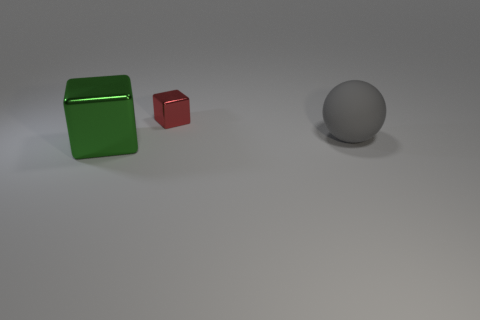Subtract all red blocks. How many blocks are left? 1 Add 2 gray metal blocks. How many objects exist? 5 Subtract 0 red cylinders. How many objects are left? 3 Subtract all balls. How many objects are left? 2 Subtract all gray blocks. Subtract all gray spheres. How many blocks are left? 2 Subtract all tiny gray rubber cubes. Subtract all green metallic blocks. How many objects are left? 2 Add 2 large objects. How many large objects are left? 4 Add 3 tiny blocks. How many tiny blocks exist? 4 